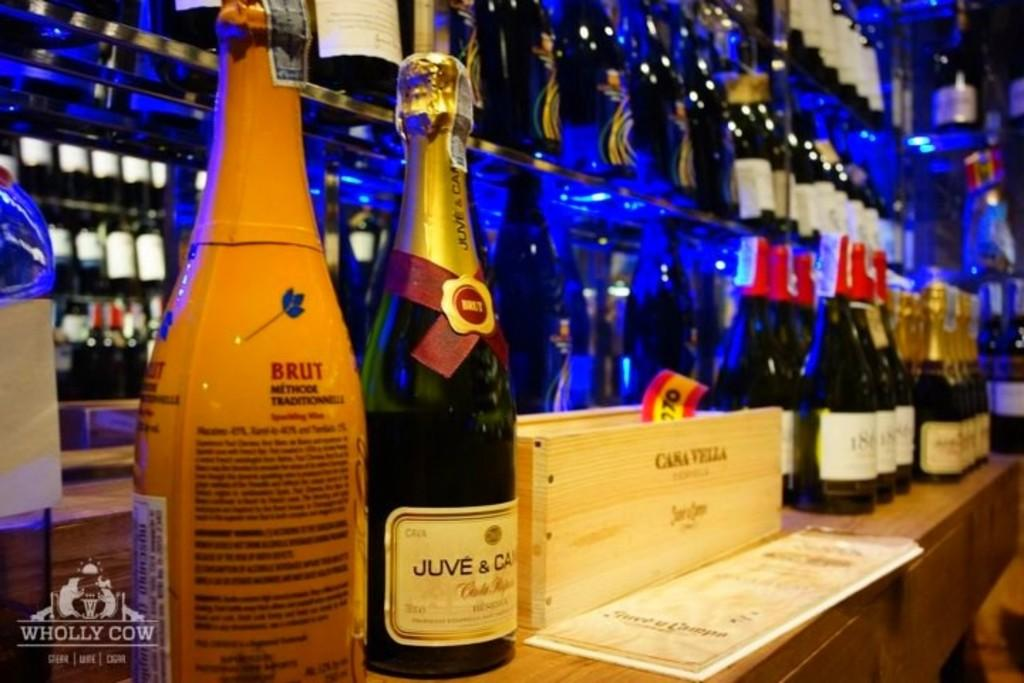What is the main object in the image? There is a table in the image. What is placed on the table? There are bottles arranged on the table. How many lizards can be seen crawling on the table in the image? There are no lizards present in the image; it only shows a table with bottles arranged on it. What type of crime is being committed in the image? There is no crime depicted in the image; it only shows a table with bottles arranged on it. 